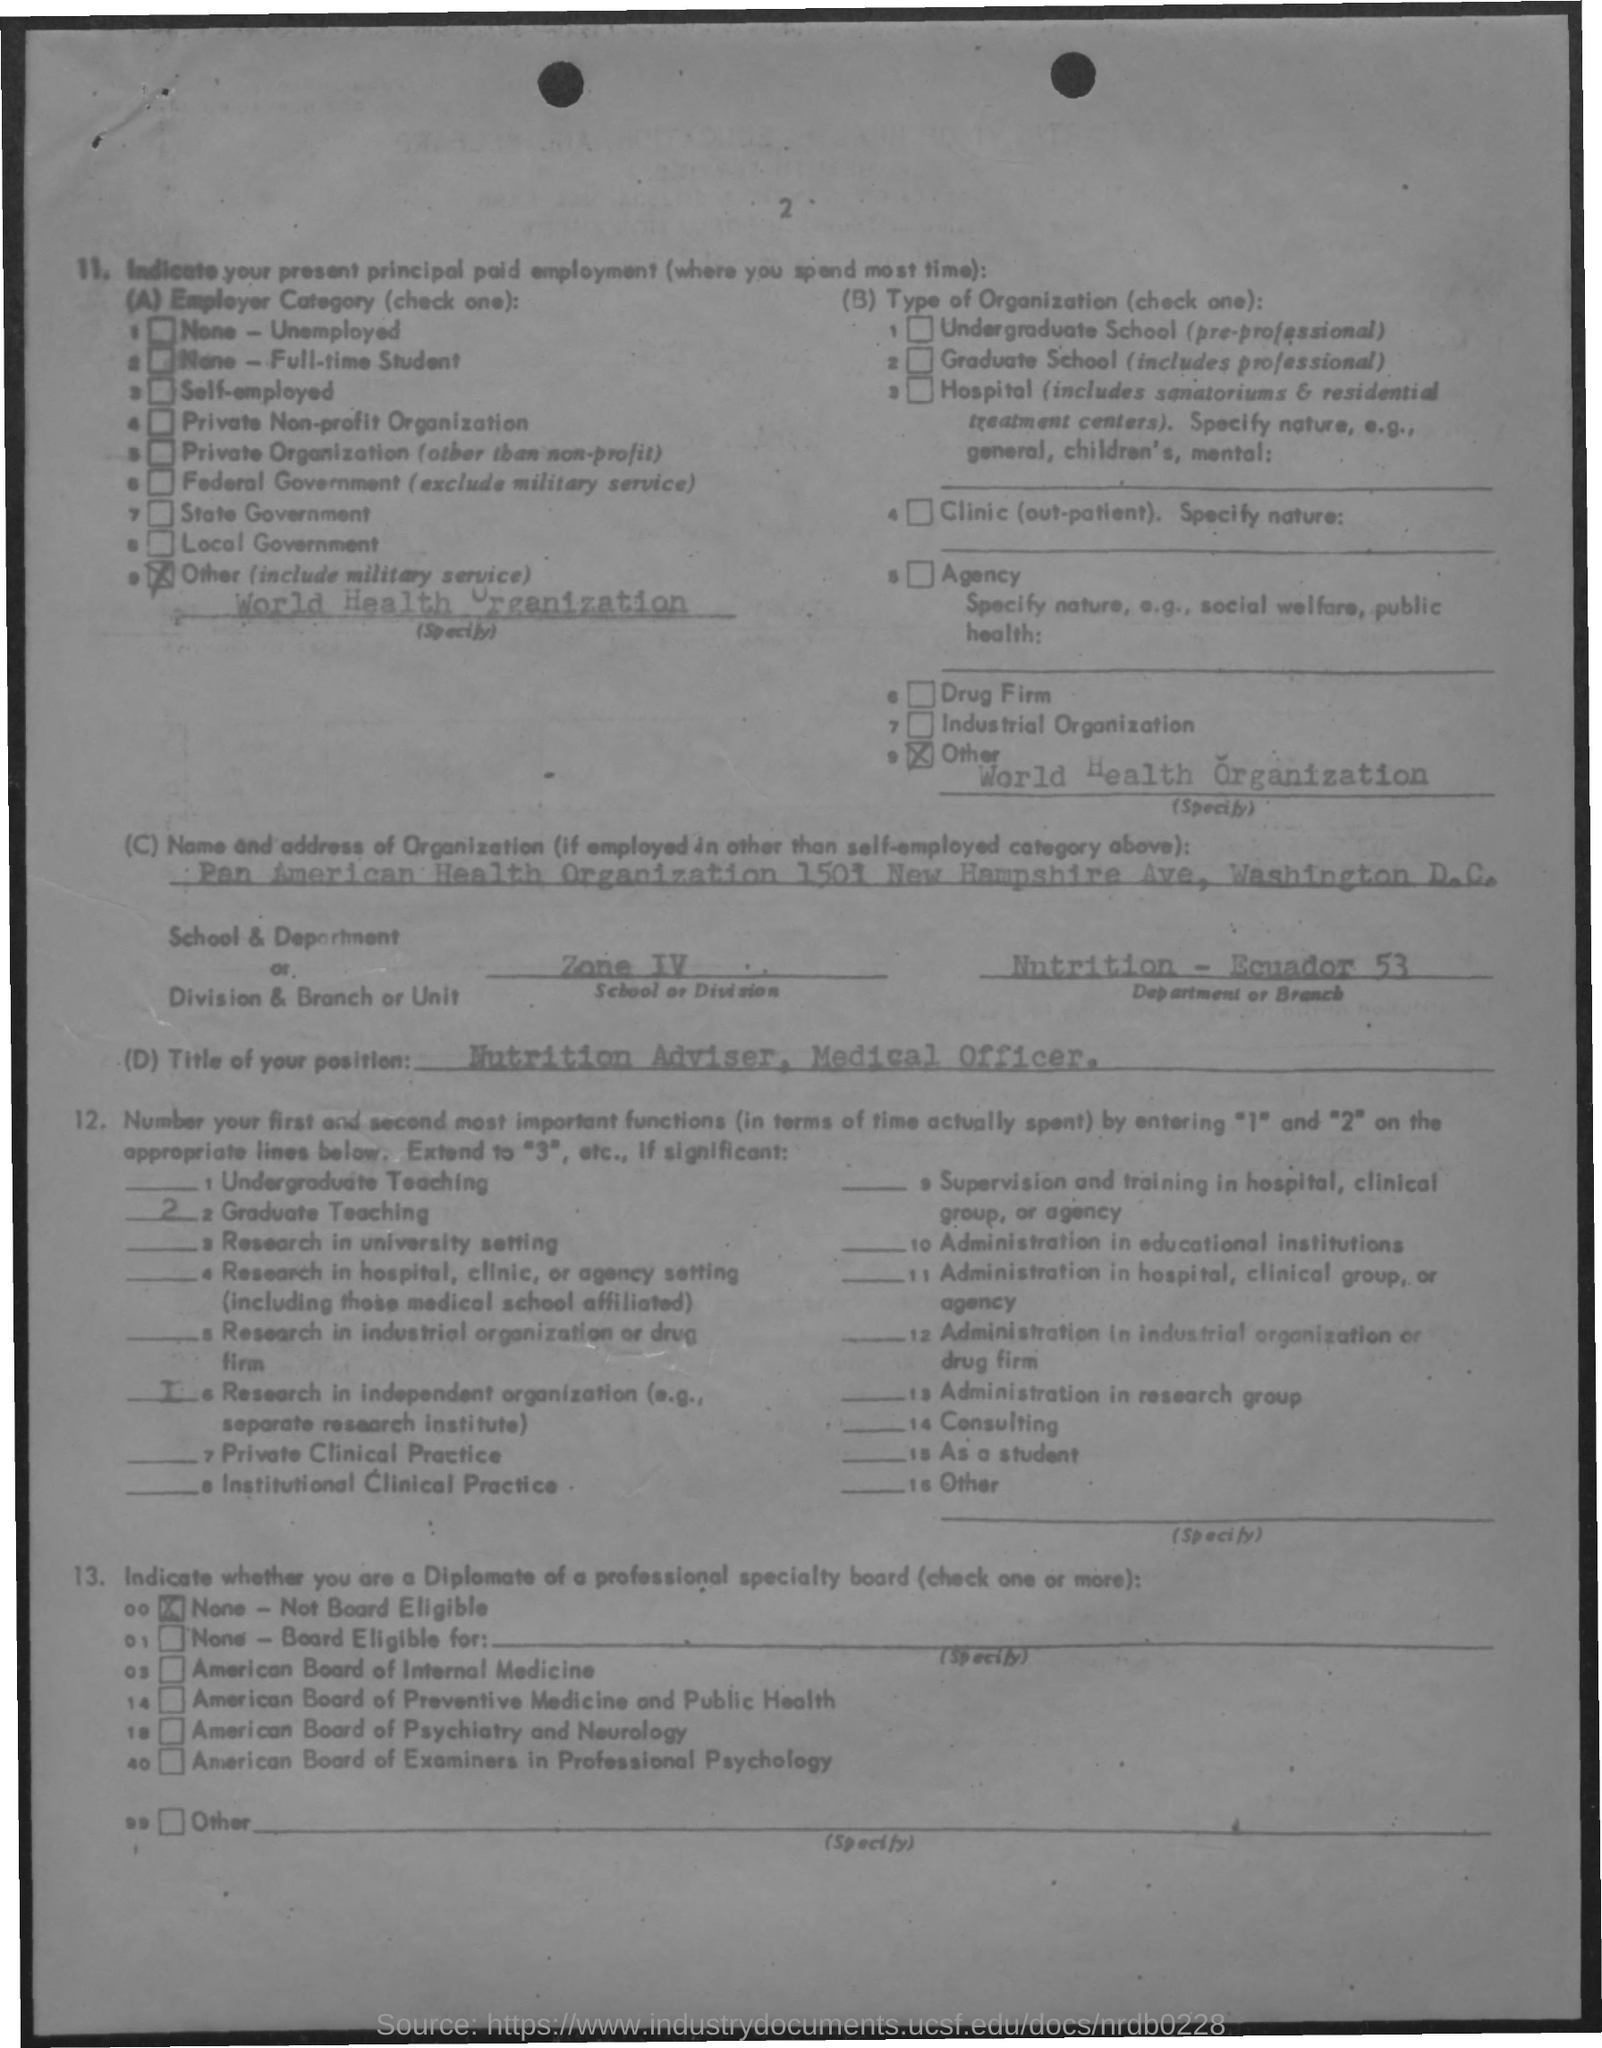Which organization is the applicant's employer?
Ensure brevity in your answer.  World Health Organization. What's the Title of Position?
Give a very brief answer. Nutrition Adviser, Medical Officer. Which Department Does the applicant belong to?
Offer a terse response. Nutrition. How many Graduate Teachings were there?
Ensure brevity in your answer.  2. 